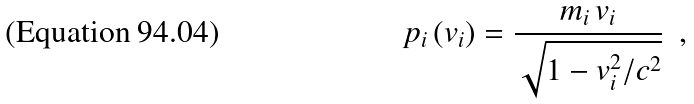<formula> <loc_0><loc_0><loc_500><loc_500>p _ { i } \, ( v _ { i } ) = \frac { m _ { i } \, v _ { i } } { \sqrt { 1 - v _ { i } ^ { 2 } / c ^ { 2 } } } \ \ ,</formula> 